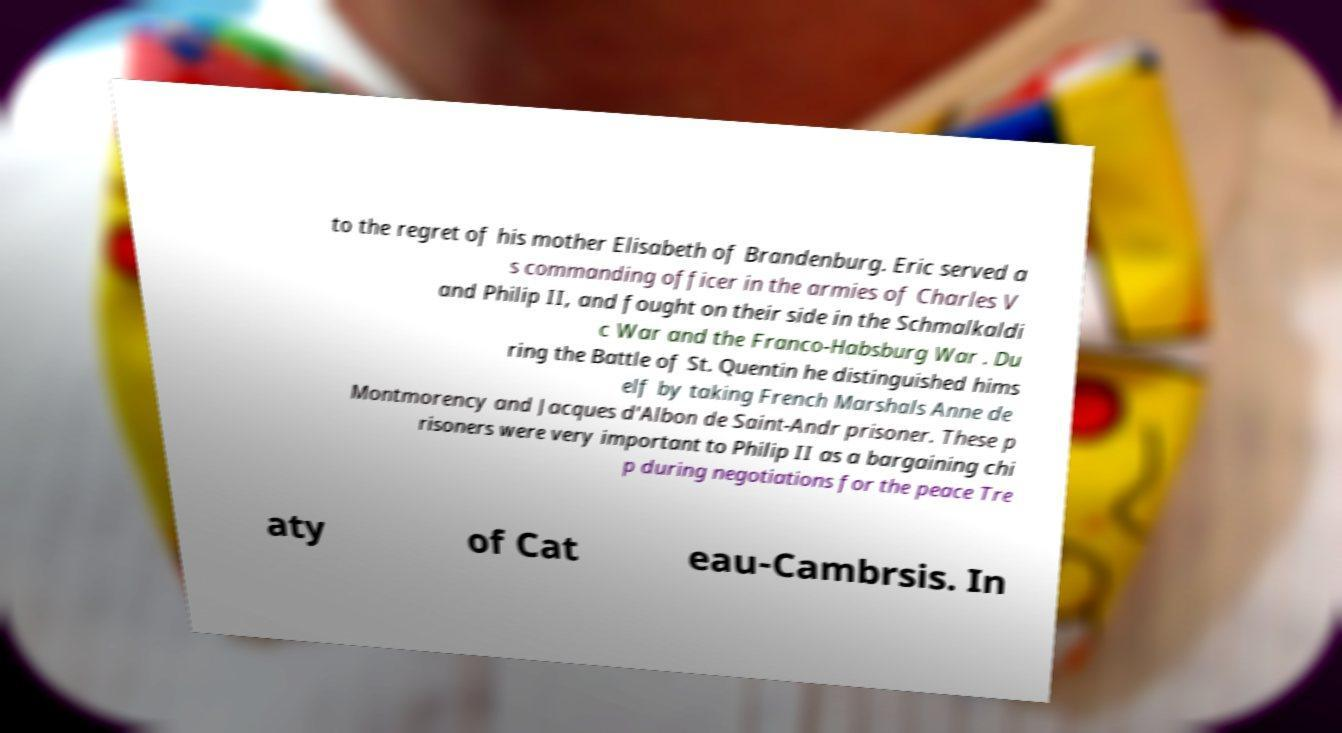Could you extract and type out the text from this image? to the regret of his mother Elisabeth of Brandenburg. Eric served a s commanding officer in the armies of Charles V and Philip II, and fought on their side in the Schmalkaldi c War and the Franco-Habsburg War . Du ring the Battle of St. Quentin he distinguished hims elf by taking French Marshals Anne de Montmorency and Jacques d'Albon de Saint-Andr prisoner. These p risoners were very important to Philip II as a bargaining chi p during negotiations for the peace Tre aty of Cat eau-Cambrsis. In 